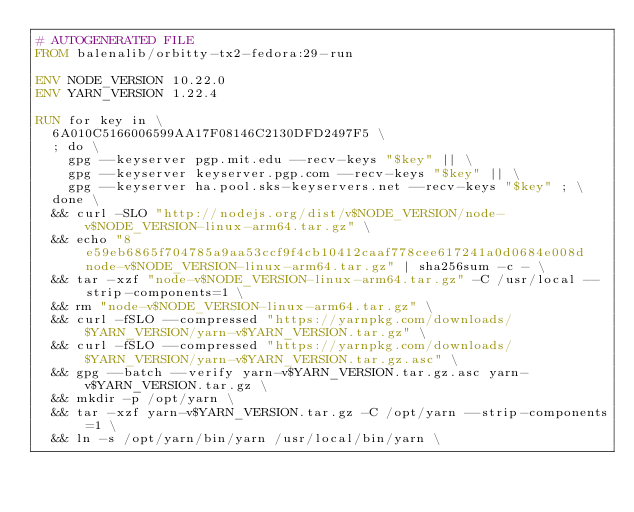Convert code to text. <code><loc_0><loc_0><loc_500><loc_500><_Dockerfile_># AUTOGENERATED FILE
FROM balenalib/orbitty-tx2-fedora:29-run

ENV NODE_VERSION 10.22.0
ENV YARN_VERSION 1.22.4

RUN for key in \
	6A010C5166006599AA17F08146C2130DFD2497F5 \
	; do \
		gpg --keyserver pgp.mit.edu --recv-keys "$key" || \
		gpg --keyserver keyserver.pgp.com --recv-keys "$key" || \
		gpg --keyserver ha.pool.sks-keyservers.net --recv-keys "$key" ; \
	done \
	&& curl -SLO "http://nodejs.org/dist/v$NODE_VERSION/node-v$NODE_VERSION-linux-arm64.tar.gz" \
	&& echo "8e59eb6865f704785a9aa53ccf9f4cb10412caaf778cee617241a0d0684e008d  node-v$NODE_VERSION-linux-arm64.tar.gz" | sha256sum -c - \
	&& tar -xzf "node-v$NODE_VERSION-linux-arm64.tar.gz" -C /usr/local --strip-components=1 \
	&& rm "node-v$NODE_VERSION-linux-arm64.tar.gz" \
	&& curl -fSLO --compressed "https://yarnpkg.com/downloads/$YARN_VERSION/yarn-v$YARN_VERSION.tar.gz" \
	&& curl -fSLO --compressed "https://yarnpkg.com/downloads/$YARN_VERSION/yarn-v$YARN_VERSION.tar.gz.asc" \
	&& gpg --batch --verify yarn-v$YARN_VERSION.tar.gz.asc yarn-v$YARN_VERSION.tar.gz \
	&& mkdir -p /opt/yarn \
	&& tar -xzf yarn-v$YARN_VERSION.tar.gz -C /opt/yarn --strip-components=1 \
	&& ln -s /opt/yarn/bin/yarn /usr/local/bin/yarn \</code> 